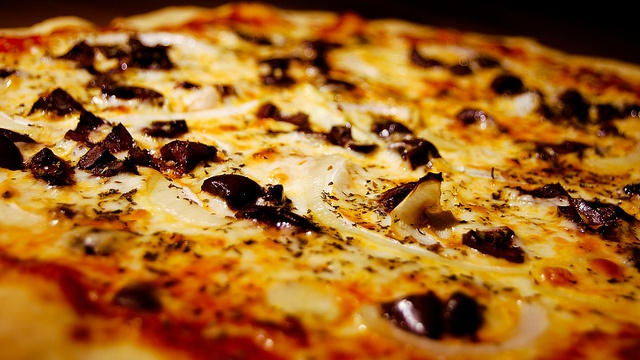Describe the objects in this image and their specific colors. I can see a pizza in red, orange, maroon, black, and tan tones in this image. 